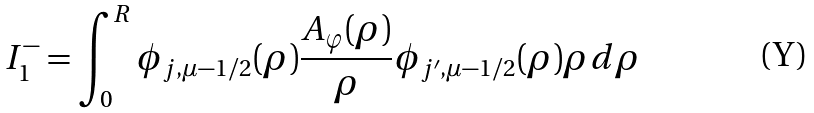<formula> <loc_0><loc_0><loc_500><loc_500>I _ { 1 } ^ { - } = \int _ { 0 } ^ { R } \phi _ { j , \mu - 1 / 2 } ( \rho ) \frac { A _ { \varphi } ( \rho ) } { \rho } \phi _ { j ^ { \prime } , \mu - 1 / 2 } ( \rho ) \rho d \rho</formula> 